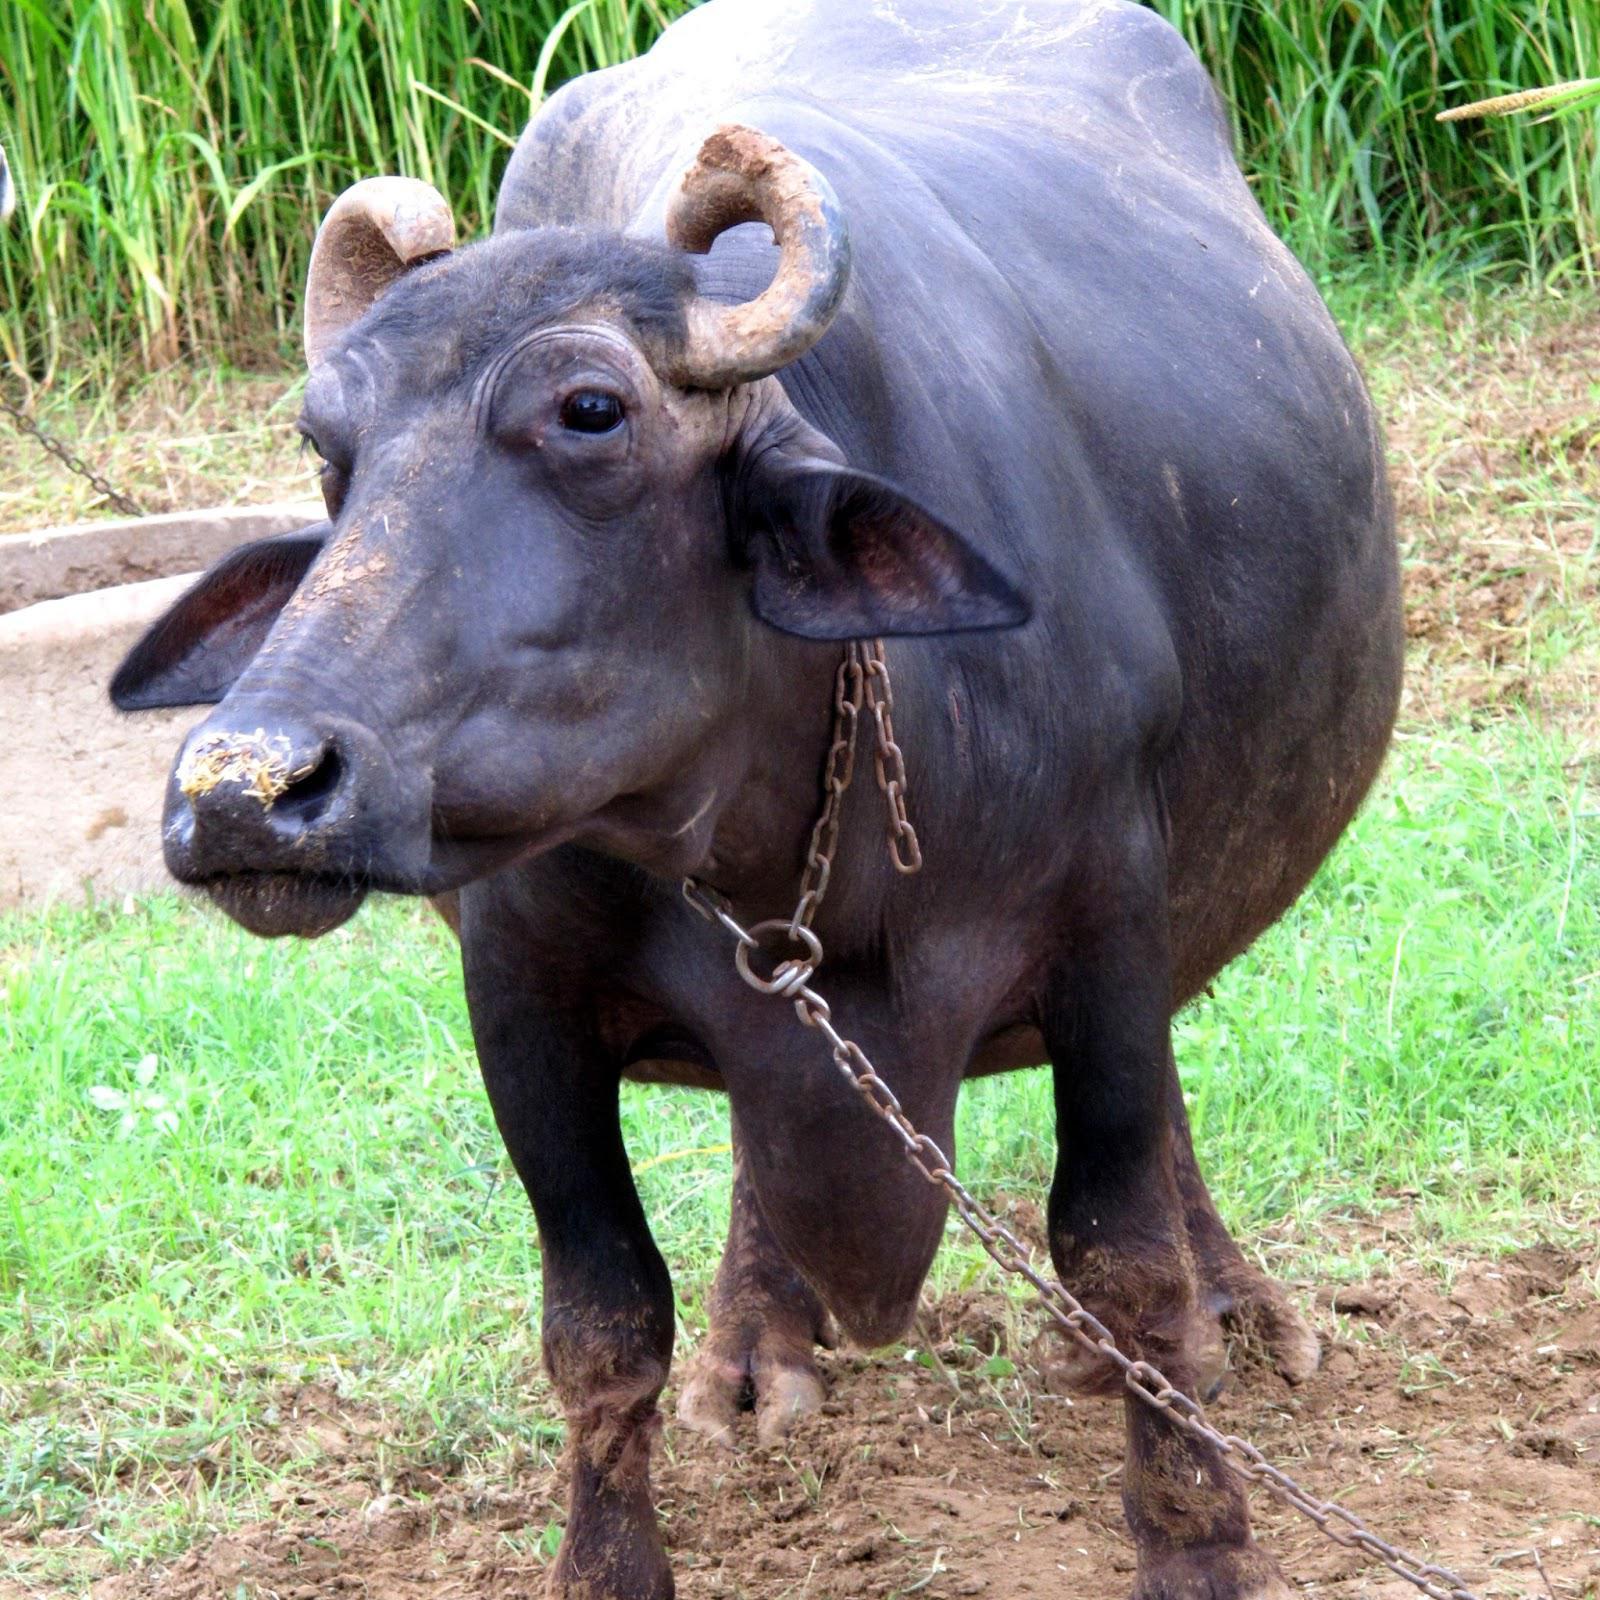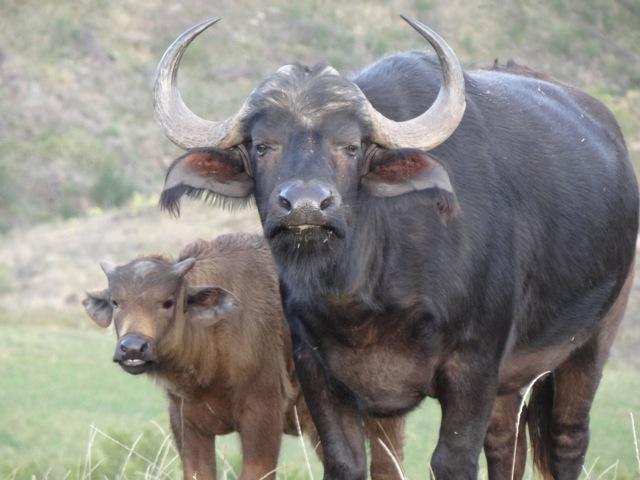The first image is the image on the left, the second image is the image on the right. Given the left and right images, does the statement "There are two buffalo." hold true? Answer yes or no. No. 